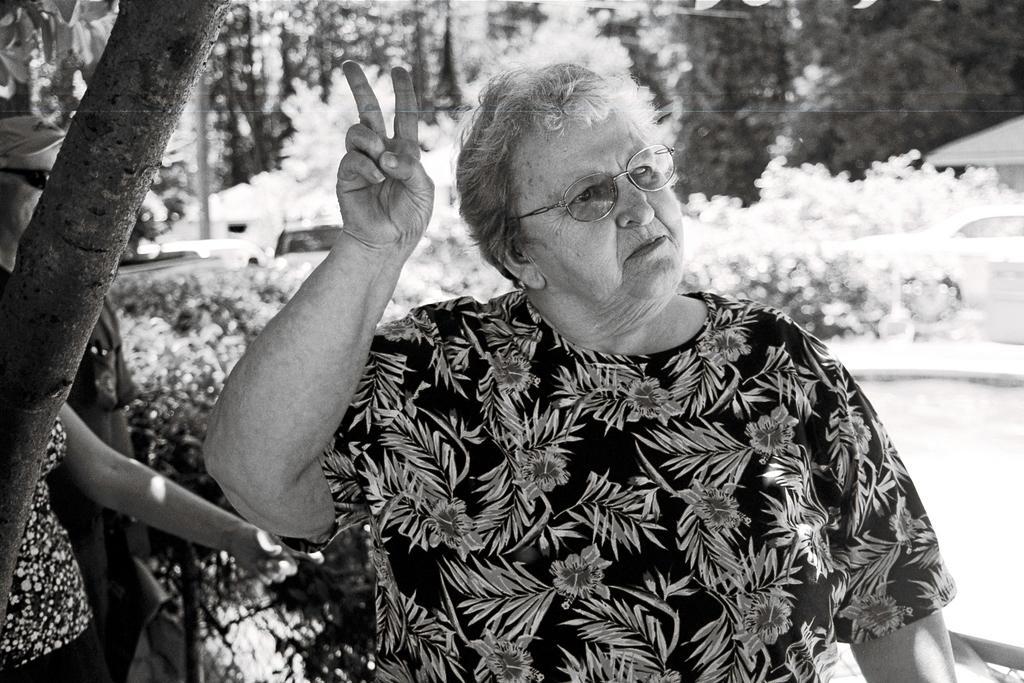How would you summarize this image in a sentence or two? In this picture I can see few people standing I can see a man showing a victory symbol with her hand and she wore spectacles and I can see a man standing on the side and he wore a cap on his head and sunglasses and I can see trees and few plants. 